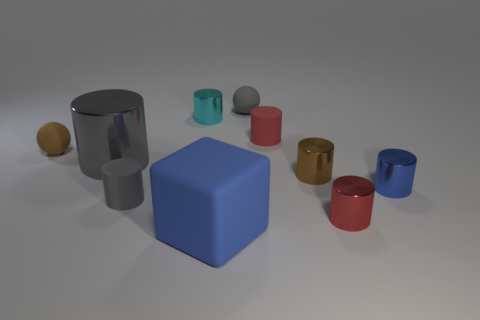There is a gray rubber thing that is behind the large object behind the blue rubber thing; how many cyan metallic things are to the right of it?
Your answer should be very brief. 0. There is a blue thing that is on the left side of the tiny gray matte object that is right of the large blue thing; what size is it?
Ensure brevity in your answer.  Large. What size is the cyan object that is made of the same material as the tiny blue object?
Your answer should be very brief. Small. The gray object that is both behind the tiny brown metal cylinder and on the right side of the big gray thing has what shape?
Provide a short and direct response. Sphere. Are there an equal number of red matte objects in front of the red shiny object and tiny purple cylinders?
Your answer should be compact. Yes. What number of things are either tiny gray balls or small shiny cylinders that are behind the big gray metallic thing?
Give a very brief answer. 2. Are there any large gray metallic things that have the same shape as the tiny blue metallic object?
Ensure brevity in your answer.  Yes. Are there an equal number of tiny spheres that are on the left side of the big gray metallic object and small rubber cylinders behind the tiny blue metallic object?
Make the answer very short. Yes. What number of gray things are either tiny shiny spheres or small things?
Provide a short and direct response. 2. What number of shiny cylinders have the same size as the blue matte object?
Your answer should be compact. 1. 